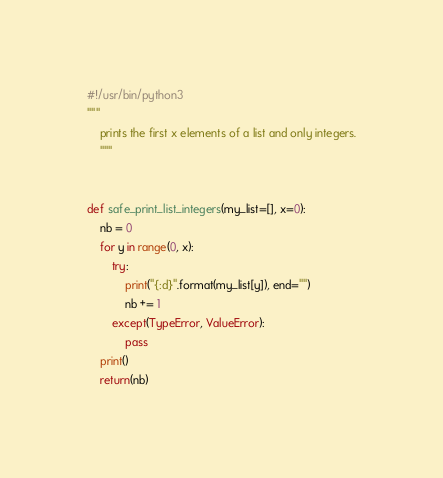<code> <loc_0><loc_0><loc_500><loc_500><_Python_>#!/usr/bin/python3
"""
    prints the first x elements of a list and only integers.
    """


def safe_print_list_integers(my_list=[], x=0):
    nb = 0
    for y in range(0, x):
        try:
            print("{:d}".format(my_list[y]), end="")
            nb += 1
        except(TypeError, ValueError):
            pass
    print()
    return(nb)
</code> 